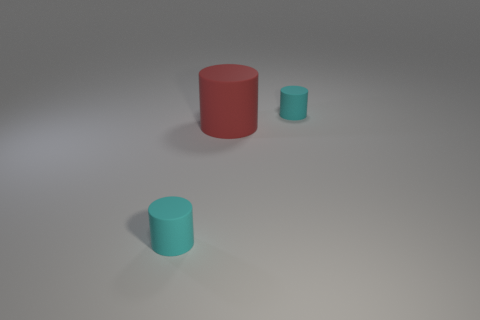There is a cyan matte cylinder behind the cyan thing on the left side of the big red rubber thing; what is its size?
Keep it short and to the point. Small. What number of other things are the same size as the red rubber thing?
Offer a very short reply. 0. How many small red rubber cubes are there?
Offer a terse response. 0. What number of other objects are the same shape as the large red thing?
Make the answer very short. 2. There is a tiny cylinder that is behind the rubber cylinder to the left of the red object; what is it made of?
Keep it short and to the point. Rubber. There is a large cylinder; are there any small matte objects behind it?
Offer a terse response. Yes. Is the size of the red object the same as the cyan matte object that is behind the red object?
Keep it short and to the point. No. Are there any other things that are made of the same material as the big cylinder?
Give a very brief answer. Yes. There is a rubber cylinder that is right of the big red rubber cylinder; is its size the same as the cyan matte thing in front of the red thing?
Your answer should be compact. Yes. What number of small things are either matte things or red cylinders?
Make the answer very short. 2. 